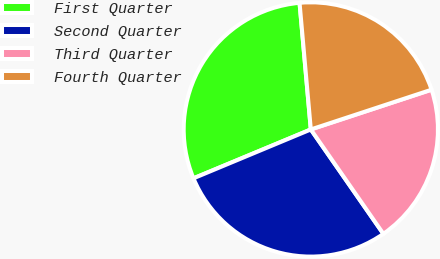Convert chart. <chart><loc_0><loc_0><loc_500><loc_500><pie_chart><fcel>First Quarter<fcel>Second Quarter<fcel>Third Quarter<fcel>Fourth Quarter<nl><fcel>29.87%<fcel>28.39%<fcel>20.4%<fcel>21.35%<nl></chart> 